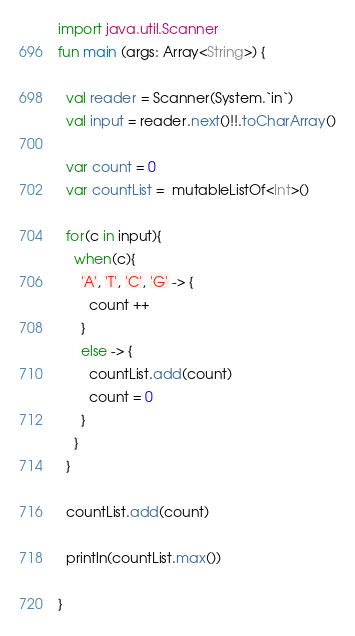<code> <loc_0><loc_0><loc_500><loc_500><_Kotlin_>import java.util.Scanner
fun main (args: Array<String>) {
  
  val reader = Scanner(System.`in`)
  val input = reader.next()!!.toCharArray()
  
  var count = 0
  var countList =  mutableListOf<Int>()
  
  for(c in input){
    when(c){
      'A', 'T', 'C', 'G' -> {
        count ++
      }
      else -> {
        countList.add(count)
        count = 0
      }
    }
  }
  
  countList.add(count)
  
  println(countList.max())
  
}</code> 